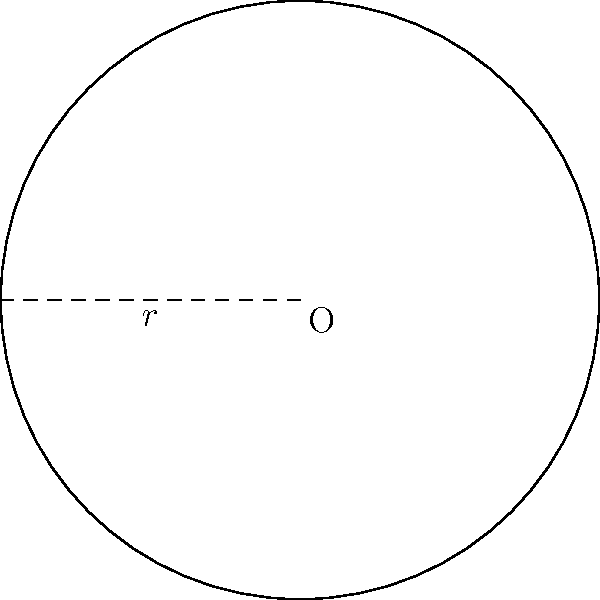In a Melkite Greek Catholic church, there is a circular stained glass window above the altar. If the radius of the window is 3 meters, calculate the area of the window. Use $\pi = 3.14$ for your calculations. How might the size and beauty of this window contribute to the spiritual experience of the congregation during the Divine Liturgy? To find the area of a circular window, we use the formula for the area of a circle:

$$A = \pi r^2$$

Where:
$A$ is the area
$\pi$ is approximately 3.14
$r$ is the radius

Given:
$r = 3$ meters
$\pi = 3.14$

Let's substitute these values into the formula:

$$A = 3.14 \times 3^2$$

Now, let's calculate:

1) First, calculate $3^2$:
   $$3^2 = 3 \times 3 = 9$$

2) Then multiply by $\pi$:
   $$A = 3.14 \times 9 = 28.26$$

Therefore, the area of the stained glass window is 28.26 square meters.

In the context of a Melkite Greek Catholic church, this large, circular window could symbolize the perfection and eternity of God. Its size allows ample natural light to illuminate the altar area, potentially creating a sense of divine presence. The beauty of the stained glass, combined with its significant size, can enhance the congregation's focus on the sacred mysteries during the Divine Liturgy, contributing to a more profound spiritual experience.
Answer: 28.26 square meters 